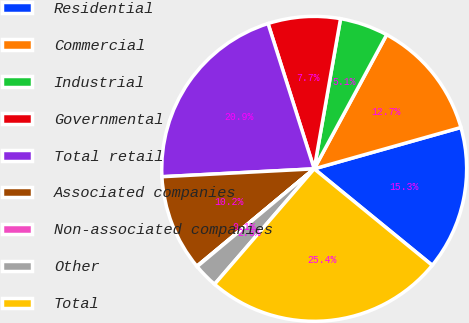Convert chart. <chart><loc_0><loc_0><loc_500><loc_500><pie_chart><fcel>Residential<fcel>Commercial<fcel>Industrial<fcel>Governmental<fcel>Total retail<fcel>Associated companies<fcel>Non-associated companies<fcel>Other<fcel>Total<nl><fcel>15.28%<fcel>12.74%<fcel>5.12%<fcel>7.66%<fcel>20.93%<fcel>10.2%<fcel>0.05%<fcel>2.59%<fcel>25.43%<nl></chart> 